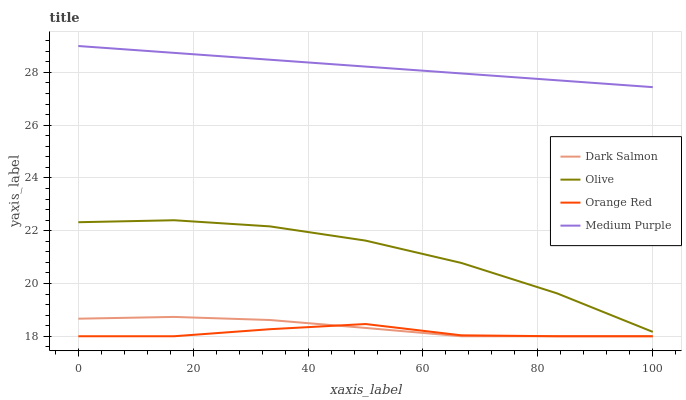Does Orange Red have the minimum area under the curve?
Answer yes or no. Yes. Does Medium Purple have the maximum area under the curve?
Answer yes or no. Yes. Does Dark Salmon have the minimum area under the curve?
Answer yes or no. No. Does Dark Salmon have the maximum area under the curve?
Answer yes or no. No. Is Medium Purple the smoothest?
Answer yes or no. Yes. Is Olive the roughest?
Answer yes or no. Yes. Is Dark Salmon the smoothest?
Answer yes or no. No. Is Dark Salmon the roughest?
Answer yes or no. No. Does Medium Purple have the lowest value?
Answer yes or no. No. Does Dark Salmon have the highest value?
Answer yes or no. No. Is Dark Salmon less than Medium Purple?
Answer yes or no. Yes. Is Medium Purple greater than Olive?
Answer yes or no. Yes. Does Dark Salmon intersect Medium Purple?
Answer yes or no. No. 